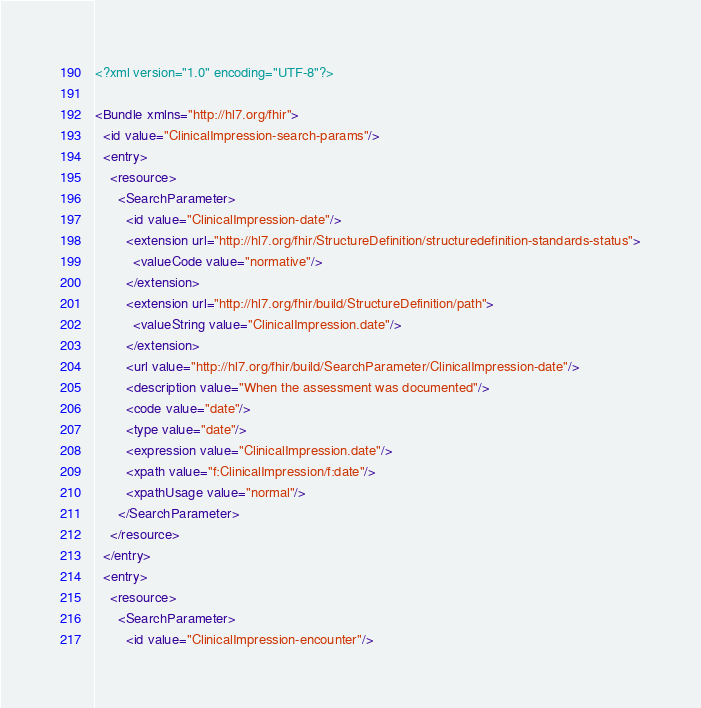<code> <loc_0><loc_0><loc_500><loc_500><_XML_><?xml version="1.0" encoding="UTF-8"?>

<Bundle xmlns="http://hl7.org/fhir">
  <id value="ClinicalImpression-search-params"/>
  <entry>
    <resource>
      <SearchParameter>
        <id value="ClinicalImpression-date"/>
        <extension url="http://hl7.org/fhir/StructureDefinition/structuredefinition-standards-status">
          <valueCode value="normative"/>
        </extension>
        <extension url="http://hl7.org/fhir/build/StructureDefinition/path">
          <valueString value="ClinicalImpression.date"/>
        </extension>
        <url value="http://hl7.org/fhir/build/SearchParameter/ClinicalImpression-date"/>
        <description value="When the assessment was documented"/>
        <code value="date"/>
        <type value="date"/>
        <expression value="ClinicalImpression.date"/>
        <xpath value="f:ClinicalImpression/f:date"/>
        <xpathUsage value="normal"/>
      </SearchParameter>
    </resource>
  </entry>
  <entry>
    <resource>
      <SearchParameter>
        <id value="ClinicalImpression-encounter"/></code> 